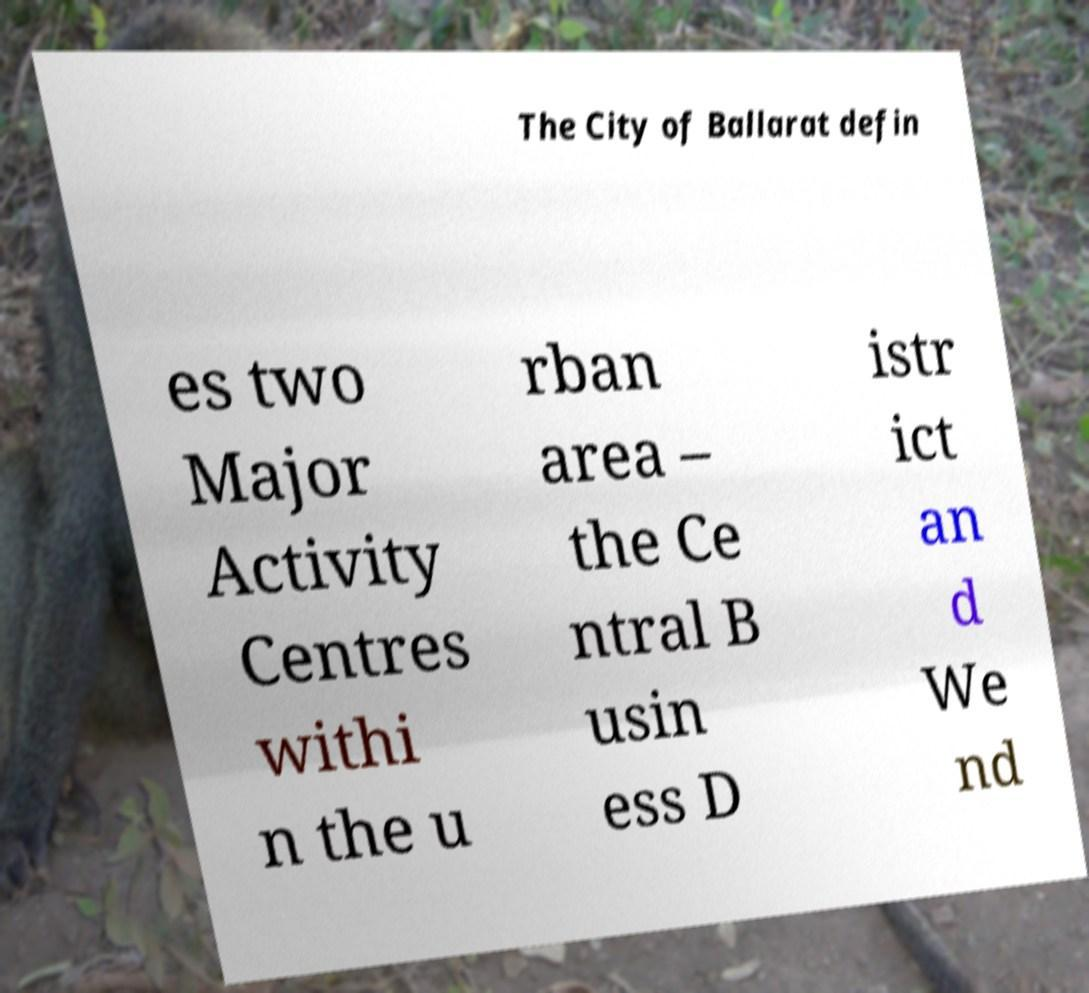There's text embedded in this image that I need extracted. Can you transcribe it verbatim? The City of Ballarat defin es two Major Activity Centres withi n the u rban area – the Ce ntral B usin ess D istr ict an d We nd 